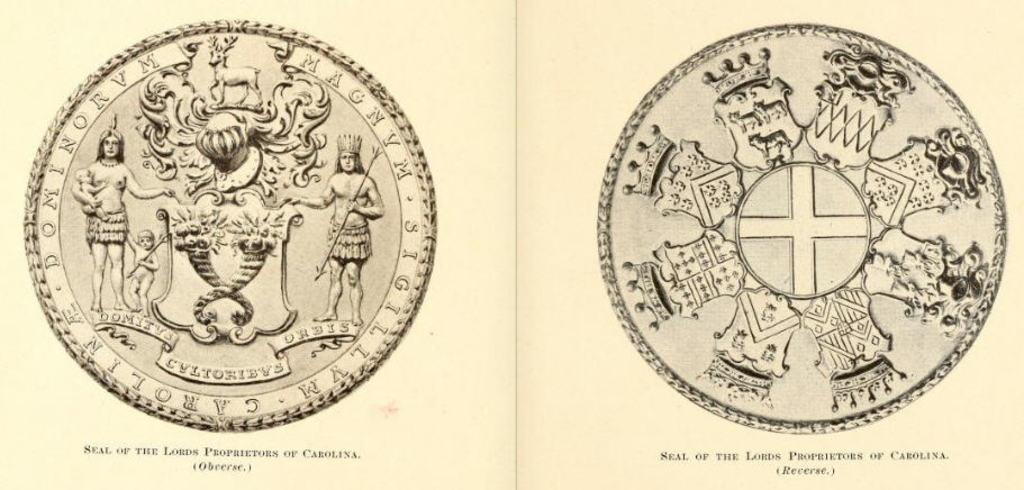<image>
Relay a brief, clear account of the picture shown. two coins with one having the seal of the lords proprietors 